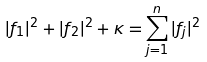Convert formula to latex. <formula><loc_0><loc_0><loc_500><loc_500>| f _ { 1 } | ^ { 2 } + | f _ { 2 } | ^ { 2 } + \kappa = \sum _ { j = 1 } ^ { n } | f _ { j } | ^ { 2 }</formula> 